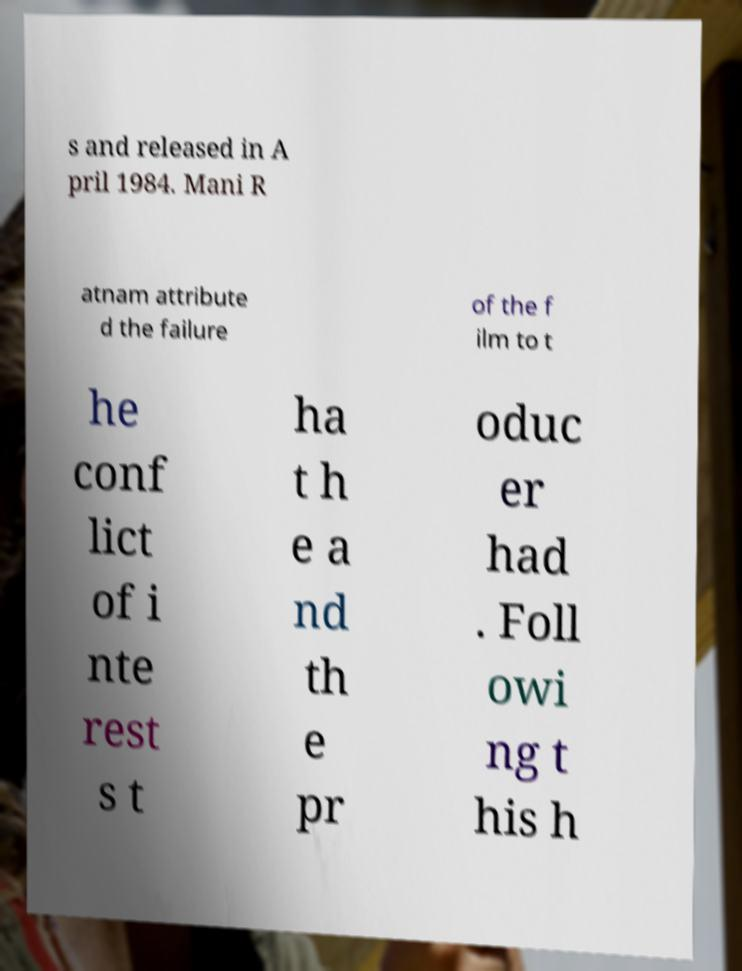Can you accurately transcribe the text from the provided image for me? s and released in A pril 1984. Mani R atnam attribute d the failure of the f ilm to t he conf lict of i nte rest s t ha t h e a nd th e pr oduc er had . Foll owi ng t his h 